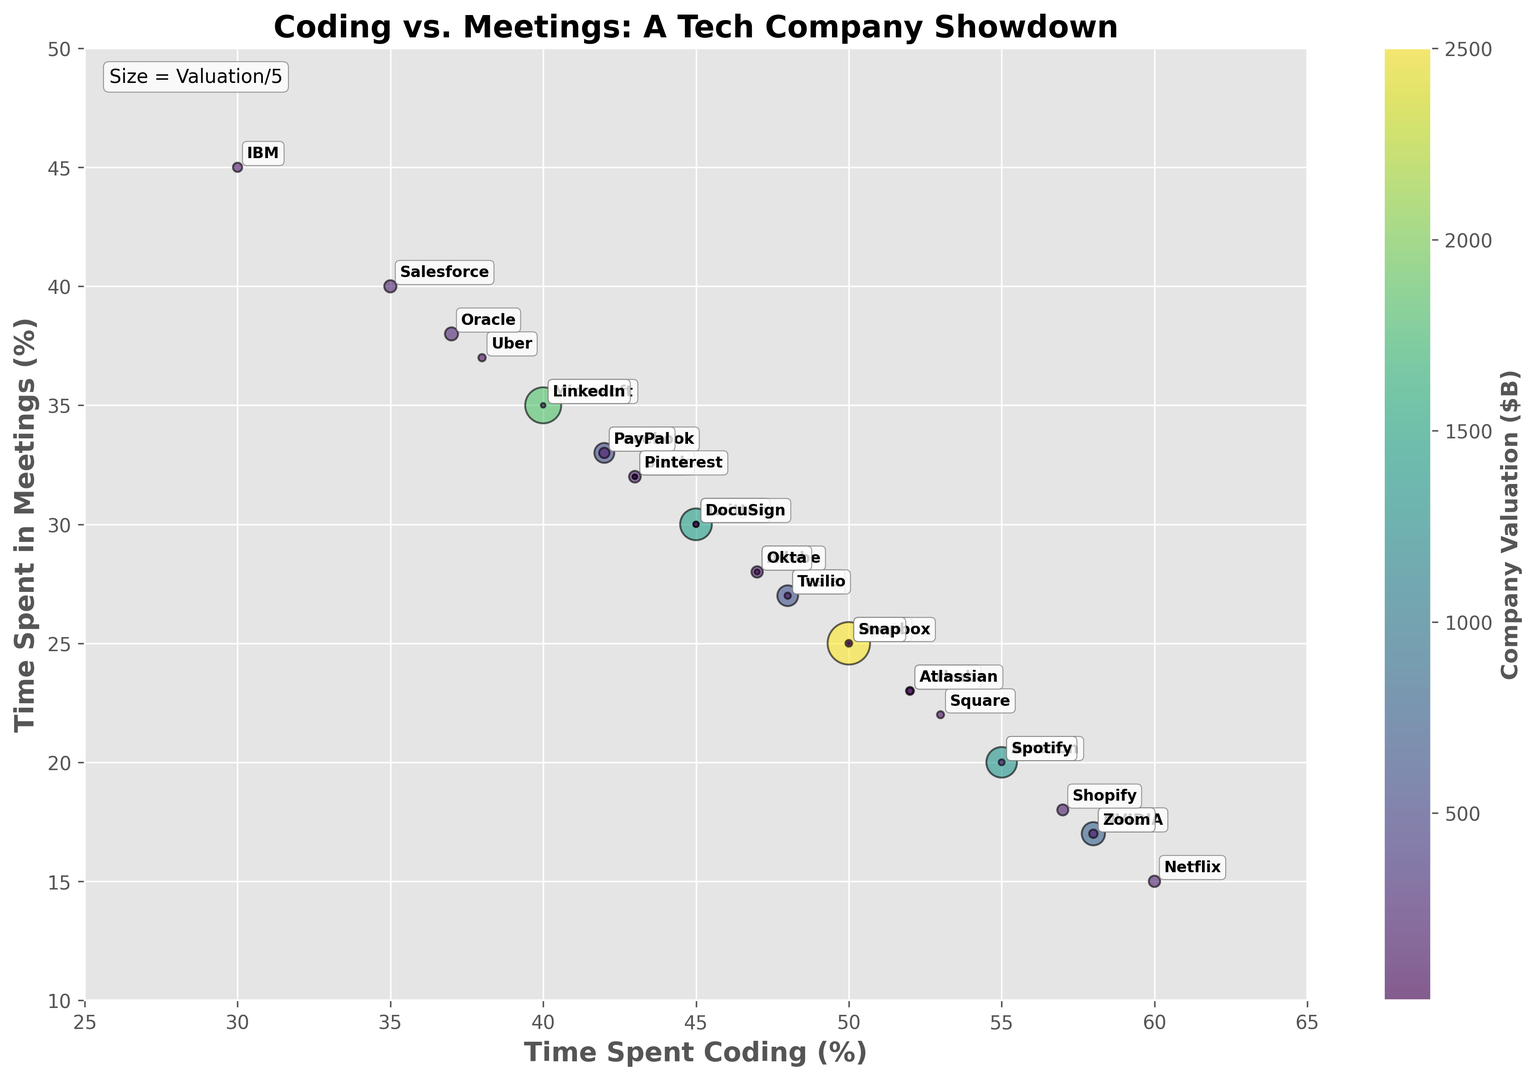Which company has the highest percentage of time spent coding? By examining the position on the x-axis, Netflix spends the most time coding at 60%.
Answer: Netflix Among Google, Apple, and Microsoft, who spends the least time in meetings? Looking at the y-axis positions for Google (30%), Apple (25%), and Microsoft (35%), Apple spends the least time in meetings.
Answer: Apple Which company has the largest valuation and how much time do they spend coding? The size of the circles indicates the valuation. Apple, with the biggest circle, has the largest valuation and spends 50% of the time coding.
Answer: Apple, 50% Which companies spend more than 50% of their time coding and less than 20% in meetings? Companies in the upper-left quadrant, focusing on coding over meetings, include Netflix, Spotify, and NVIDIA.
Answer: Netflix, Spotify, NVIDIA Are there any companies with the same time spent in meetings and coding? From the plot, Twitter, Google, and DocuSign each spend 30% of their time in meetings and 45% coding.
Answer: Twitter, Google, DocuSign Compare the valuations of Airbnb and Uber based on their bubble sizes. Airbnb's bubble is slightly larger than Uber’s, indicating a higher valuation. Specifically, Airbnb has a valuation of 90, while Uber has 75.
Answer: Airbnb has a higher valuation Which company spends the least time coding, and how much time do they spend in meetings? IBM spends the least time coding at 30% and spends 45% of the time in meetings.
Answer: IBM, 45% What is the difference in coding time between Tesla and Oracle? Tesla spends 48% coding, and Oracle spends 37% coding. Therefore, the difference is 48% - 37% = 11%.
Answer: 11% Which company's time spent in meetings is closest to Spotify's? Spotify spends 20% of their time in meetings. Both Shopify and Amazon also spend 20% of their time in meetings.
Answer: Shopify, Amazon How does the coding and meeting time of Zoom compare to Slack? Zoom spends 58% coding and 17% in meetings, while Slack spends 43% coding and 32% in meetings. Zoom spends more time coding and less in meetings compared to Slack.
Answer: Zoom spends more time coding, Slack spends more time in meetings 